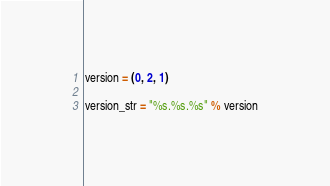Convert code to text. <code><loc_0><loc_0><loc_500><loc_500><_Python_>version = (0, 2, 1)

version_str = "%s.%s.%s" % version
</code> 